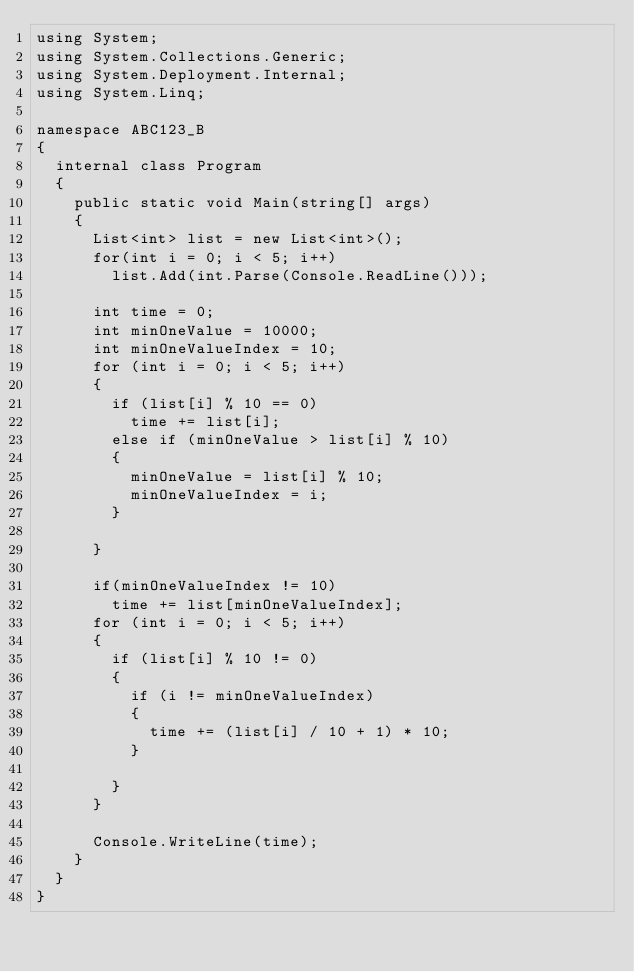Convert code to text. <code><loc_0><loc_0><loc_500><loc_500><_C#_>using System;
using System.Collections.Generic;
using System.Deployment.Internal;
using System.Linq;

namespace ABC123_B
{
	internal class Program
	{
		public static void Main(string[] args)
		{
			List<int> list = new List<int>();
			for(int i = 0; i < 5; i++)
				list.Add(int.Parse(Console.ReadLine()));
			
			int time = 0;
			int minOneValue = 10000;
			int minOneValueIndex = 10;
			for (int i = 0; i < 5; i++)
			{
				if (list[i] % 10 == 0)
					time += list[i];
				else if (minOneValue > list[i] % 10)
				{
					minOneValue = list[i] % 10;
					minOneValueIndex = i;
				}
					
			}

			if(minOneValueIndex != 10)
				time += list[minOneValueIndex];
			for (int i = 0; i < 5; i++)
			{
				if (list[i] % 10 != 0)
				{
					if (i != minOneValueIndex)
					{
						time += (list[i] / 10 + 1) * 10;
					}
						
				}
			}
			
			Console.WriteLine(time);
		}
	}
}</code> 